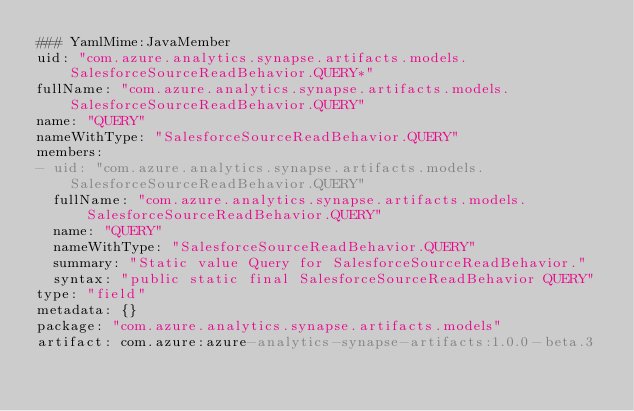<code> <loc_0><loc_0><loc_500><loc_500><_YAML_>### YamlMime:JavaMember
uid: "com.azure.analytics.synapse.artifacts.models.SalesforceSourceReadBehavior.QUERY*"
fullName: "com.azure.analytics.synapse.artifacts.models.SalesforceSourceReadBehavior.QUERY"
name: "QUERY"
nameWithType: "SalesforceSourceReadBehavior.QUERY"
members:
- uid: "com.azure.analytics.synapse.artifacts.models.SalesforceSourceReadBehavior.QUERY"
  fullName: "com.azure.analytics.synapse.artifacts.models.SalesforceSourceReadBehavior.QUERY"
  name: "QUERY"
  nameWithType: "SalesforceSourceReadBehavior.QUERY"
  summary: "Static value Query for SalesforceSourceReadBehavior."
  syntax: "public static final SalesforceSourceReadBehavior QUERY"
type: "field"
metadata: {}
package: "com.azure.analytics.synapse.artifacts.models"
artifact: com.azure:azure-analytics-synapse-artifacts:1.0.0-beta.3
</code> 